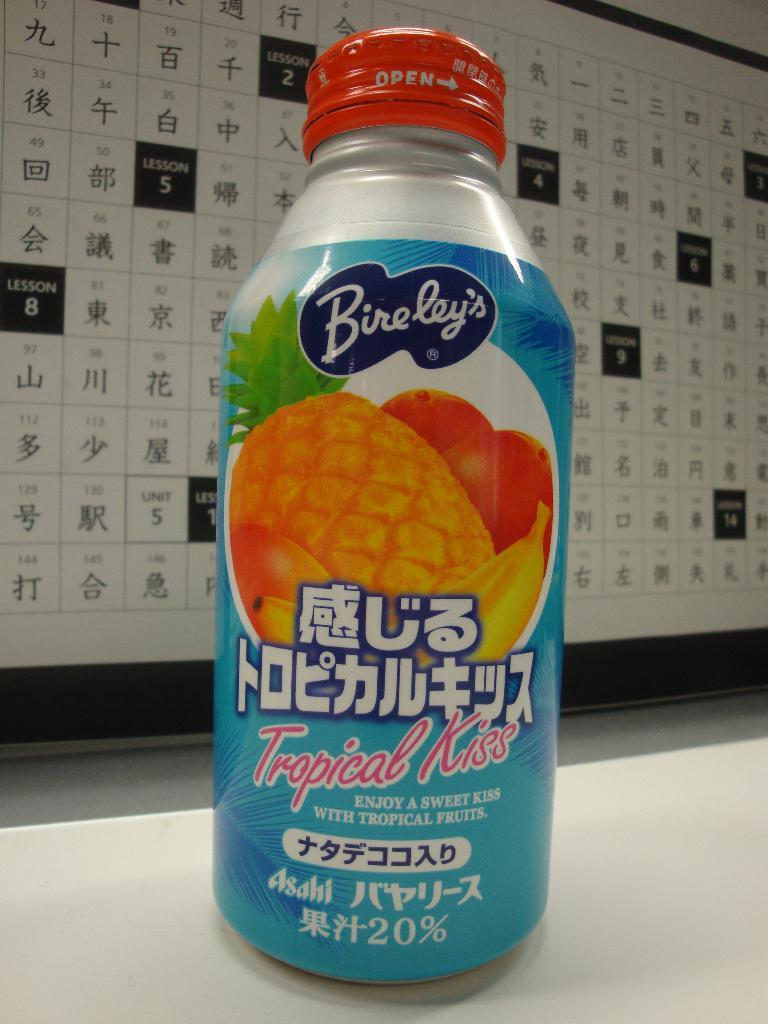Provide a one-sentence caption for the provided image. A bottle of Bireley's sitting on a table near a lot of Chinese characters on a wall. 